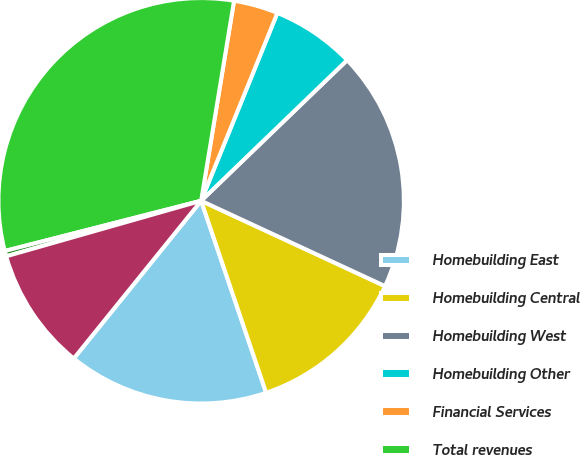<chart> <loc_0><loc_0><loc_500><loc_500><pie_chart><fcel>Homebuilding East<fcel>Homebuilding Central<fcel>Homebuilding West<fcel>Homebuilding Other<fcel>Financial Services<fcel>Total revenues<fcel>Corporate and unallocated (1)<fcel>Earnings from continuing<nl><fcel>16.01%<fcel>12.89%<fcel>19.12%<fcel>6.66%<fcel>3.54%<fcel>31.58%<fcel>0.43%<fcel>9.77%<nl></chart> 